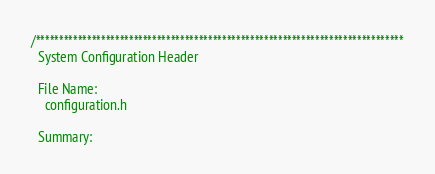<code> <loc_0><loc_0><loc_500><loc_500><_C_>/*******************************************************************************
  System Configuration Header

  File Name:
    configuration.h

  Summary:</code> 